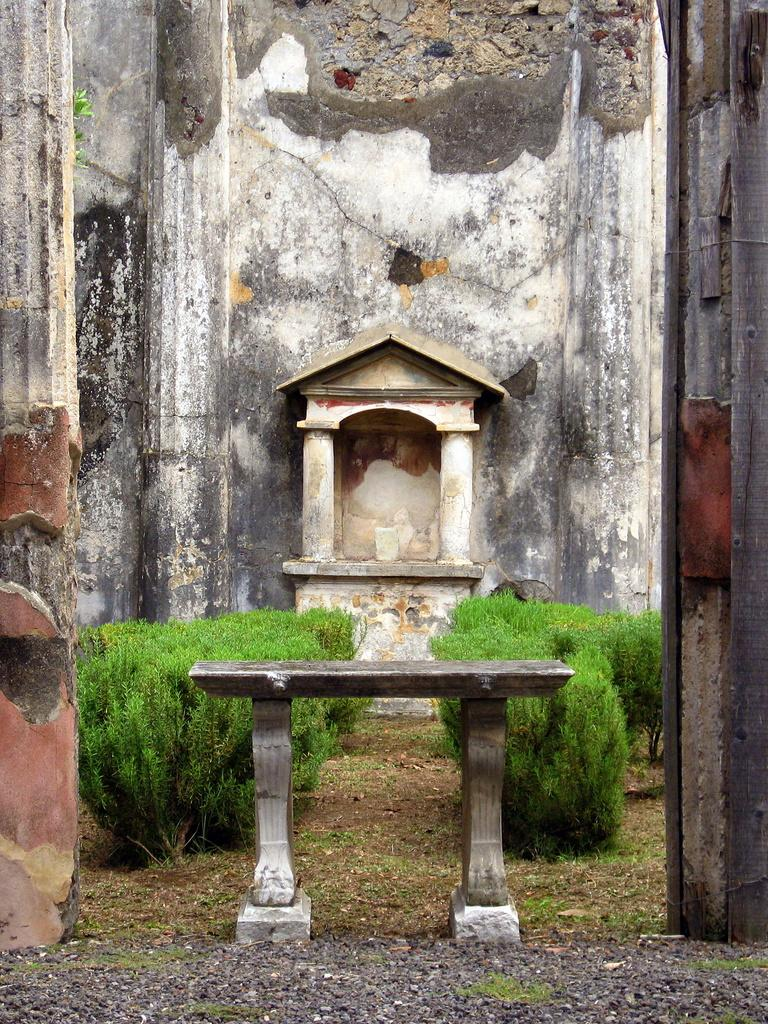What type of structure is visible in the image? There is a building in the image. What type of vegetation is present at the bottom of the image? There are bushes at the bottom of the image. What type of seating is available in the image? There is a bench in the image. What type of dress is hanging on the bench in the image? There is no dress present in the image; only a bench, bushes, and a building are visible. 